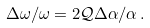<formula> <loc_0><loc_0><loc_500><loc_500>\Delta \omega / \omega = 2 \mathcal { Q } \Delta \alpha / \alpha \, .</formula> 